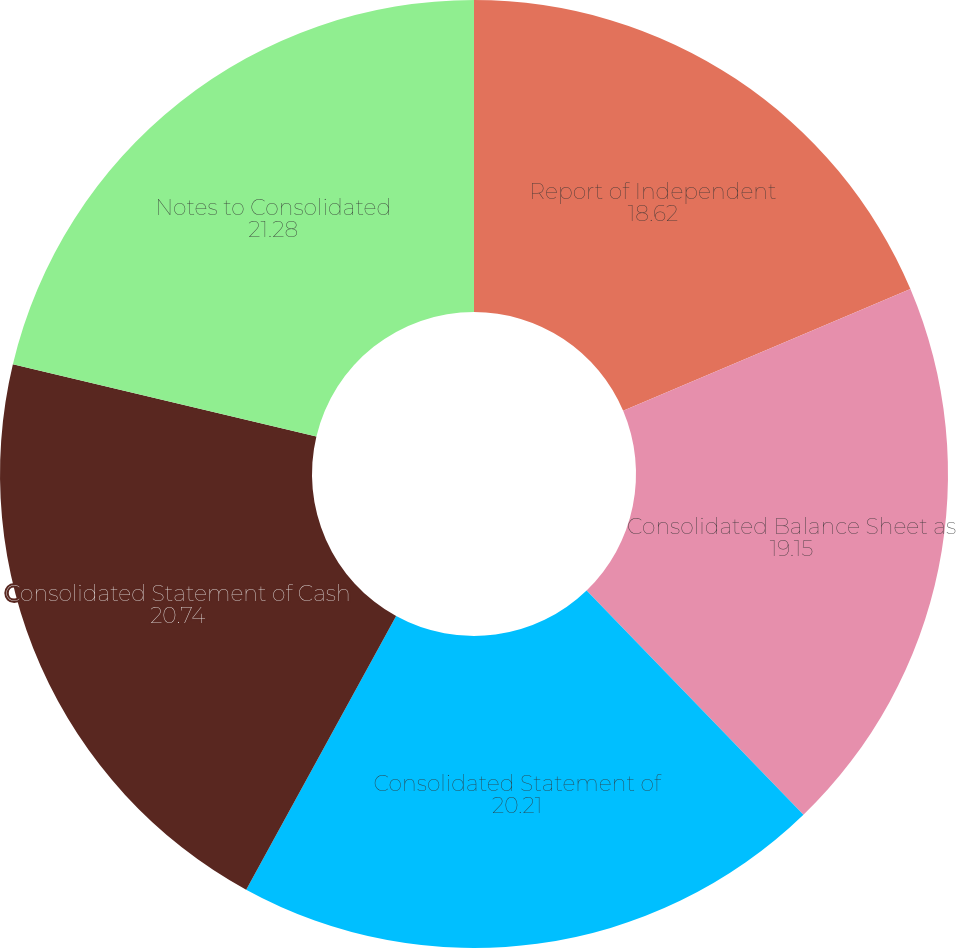Convert chart to OTSL. <chart><loc_0><loc_0><loc_500><loc_500><pie_chart><fcel>Report of Independent<fcel>Consolidated Balance Sheet as<fcel>Consolidated Statement of<fcel>Consolidated Statement of Cash<fcel>Notes to Consolidated<nl><fcel>18.62%<fcel>19.15%<fcel>20.21%<fcel>20.74%<fcel>21.28%<nl></chart> 